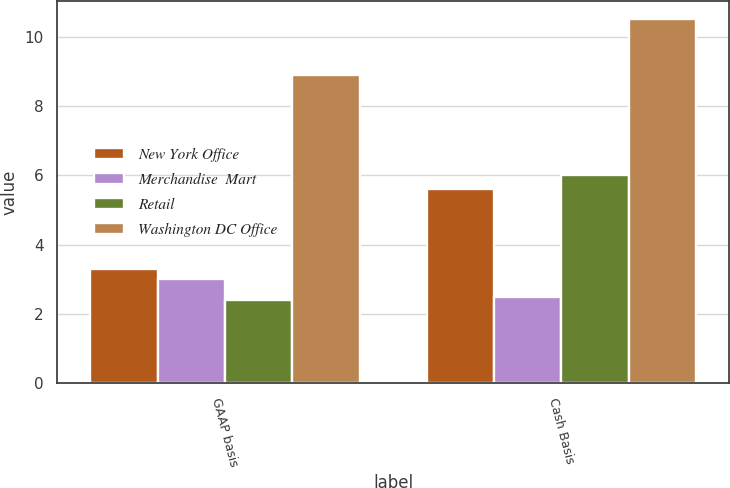Convert chart to OTSL. <chart><loc_0><loc_0><loc_500><loc_500><stacked_bar_chart><ecel><fcel>GAAP basis<fcel>Cash Basis<nl><fcel>New York Office<fcel>3.3<fcel>5.6<nl><fcel>Merchandise  Mart<fcel>3<fcel>2.5<nl><fcel>Retail<fcel>2.4<fcel>6<nl><fcel>Washington DC Office<fcel>8.9<fcel>10.5<nl></chart> 